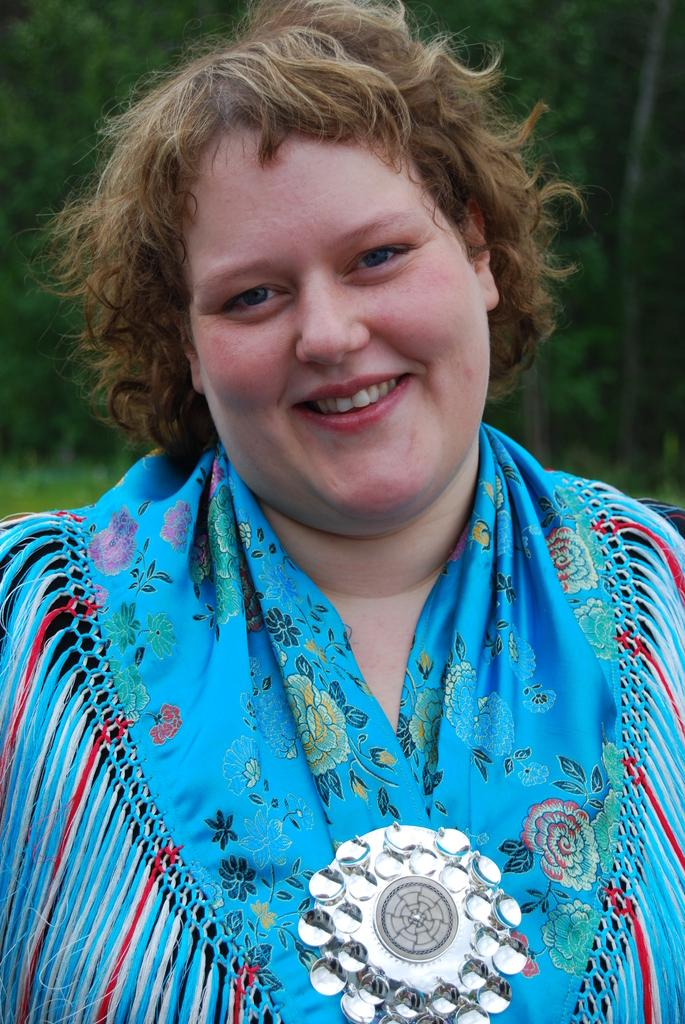Who is present in the image? There is a woman in the image. What is the woman doing in the image? The woman is standing in the image. What is the woman's facial expression in the image? The woman is smiling in the image. What can be seen in the background of the image? There are trees visible in the background of the image. What flavor of ice cream is the fireman holding in the image? There is no fireman or ice cream present in the image. 